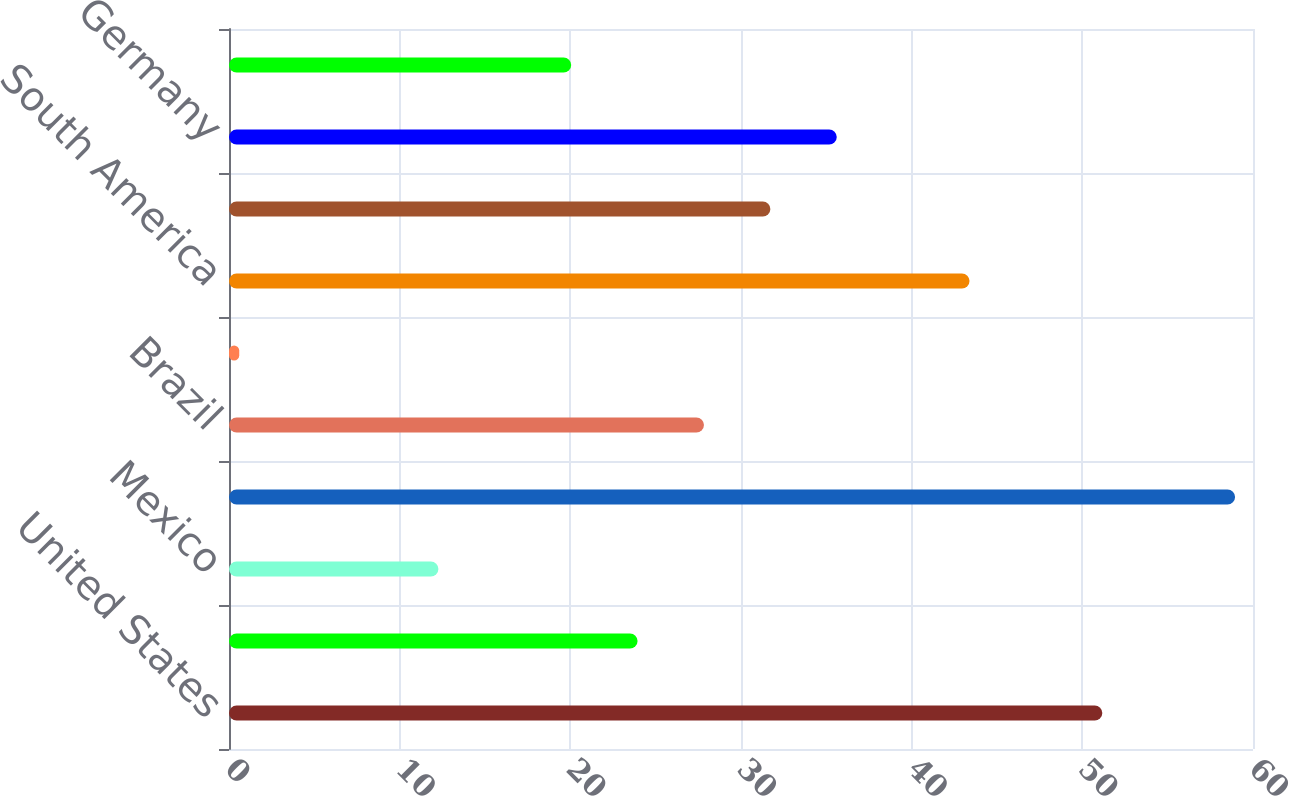<chart> <loc_0><loc_0><loc_500><loc_500><bar_chart><fcel>United States<fcel>Canada<fcel>Mexico<fcel>North America<fcel>Brazil<fcel>Argentina<fcel>South America<fcel>United Kingdom<fcel>Germany<fcel>Russia<nl><fcel>51.17<fcel>23.94<fcel>12.27<fcel>58.95<fcel>27.83<fcel>0.6<fcel>43.39<fcel>31.72<fcel>35.61<fcel>20.05<nl></chart> 